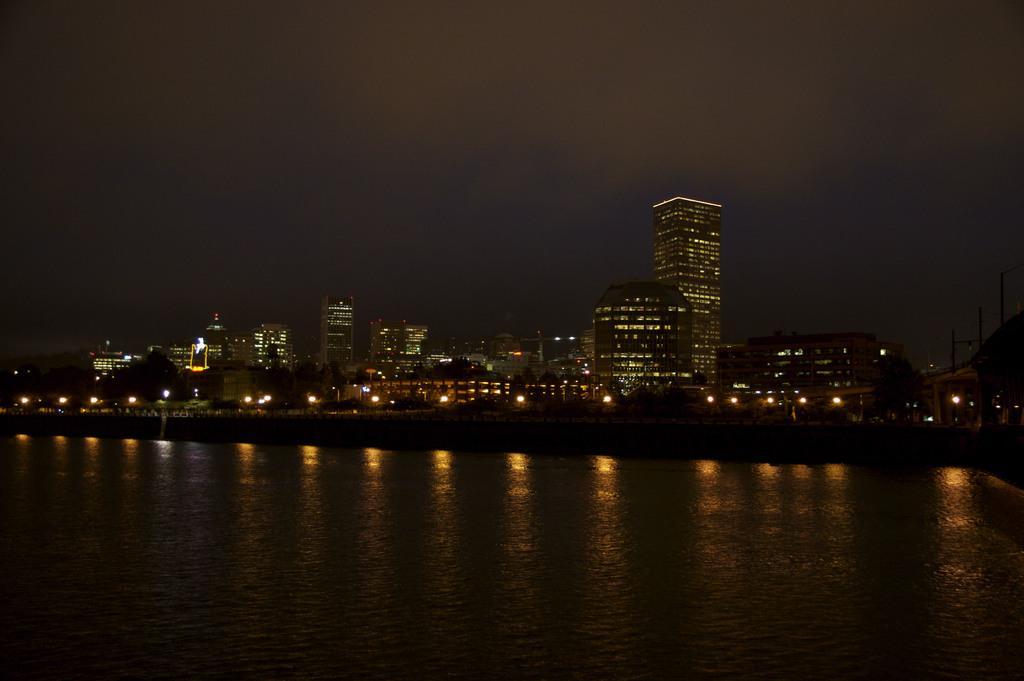Can you describe this image briefly? This is a picture of a city , where there is water , skyscrapers, and in the background there is sky. 